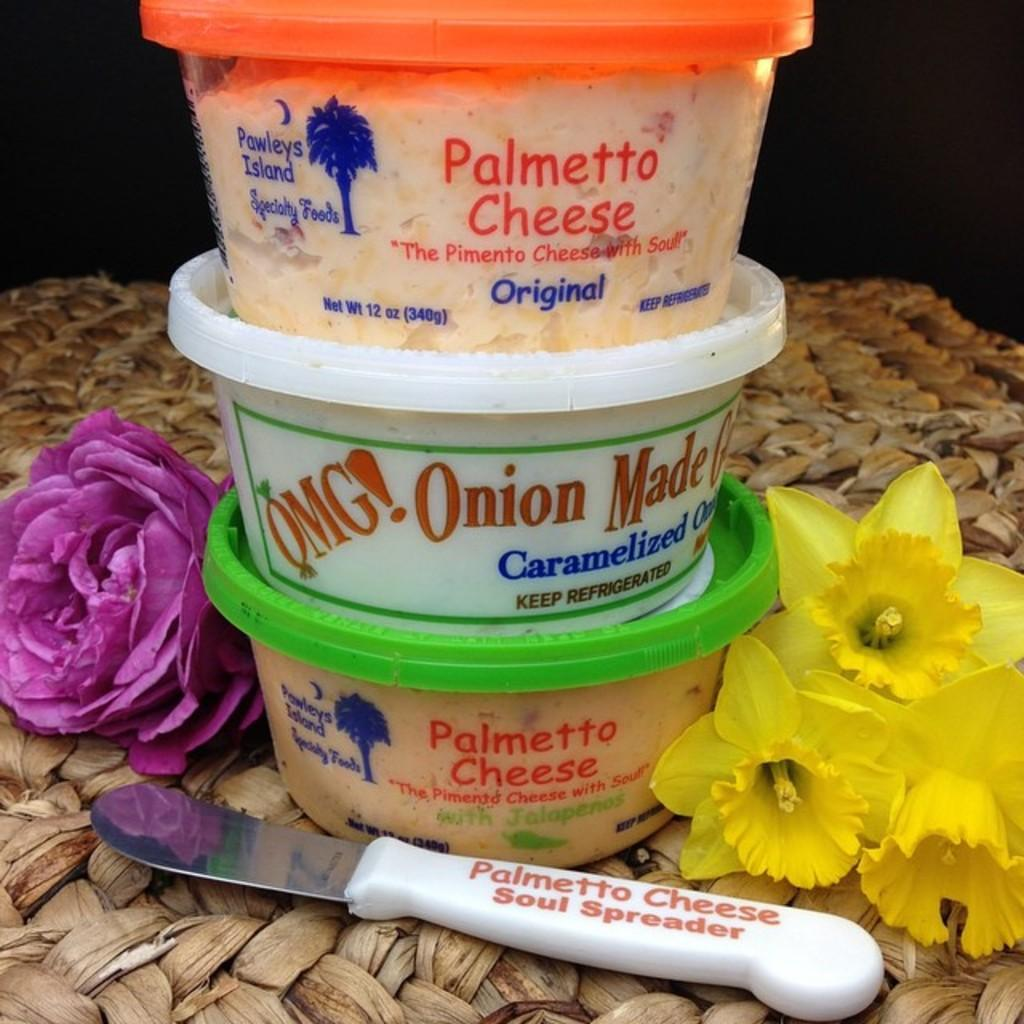<image>
Summarize the visual content of the image. a container with the word onion on the front 